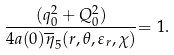<formula> <loc_0><loc_0><loc_500><loc_500>\frac { ( q _ { 0 } ^ { 2 } + Q _ { 0 } ^ { 2 } ) } { 4 a ( 0 ) \overline { \eta } _ { 5 } ( r , \theta , \varepsilon _ { r } , \chi ) } { = 1 . }</formula> 